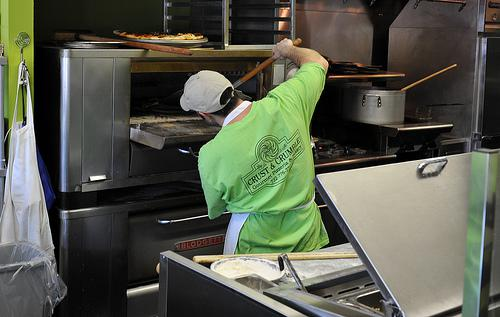Question: what room is this?
Choices:
A. Kitchen.
B. Bedroom.
C. Dining Room.
D. Living room.
Answer with the letter. Answer: A Question: what is the color of the wall?
Choices:
A. Beige.
B. Green.
C. White.
D. Blue.
Answer with the letter. Answer: B Question: how many aprons?
Choices:
A. 2.
B. 3.
C. 1.
D. 0.
Answer with the letter. Answer: A Question: what is the color of the apron?
Choices:
A. Pink.
B. Red.
C. Green.
D. White.
Answer with the letter. Answer: D Question: what is in the man head?
Choices:
A. A bird.
B. Cap.
C. A hat.
D. A squirrel.
Answer with the letter. Answer: B 